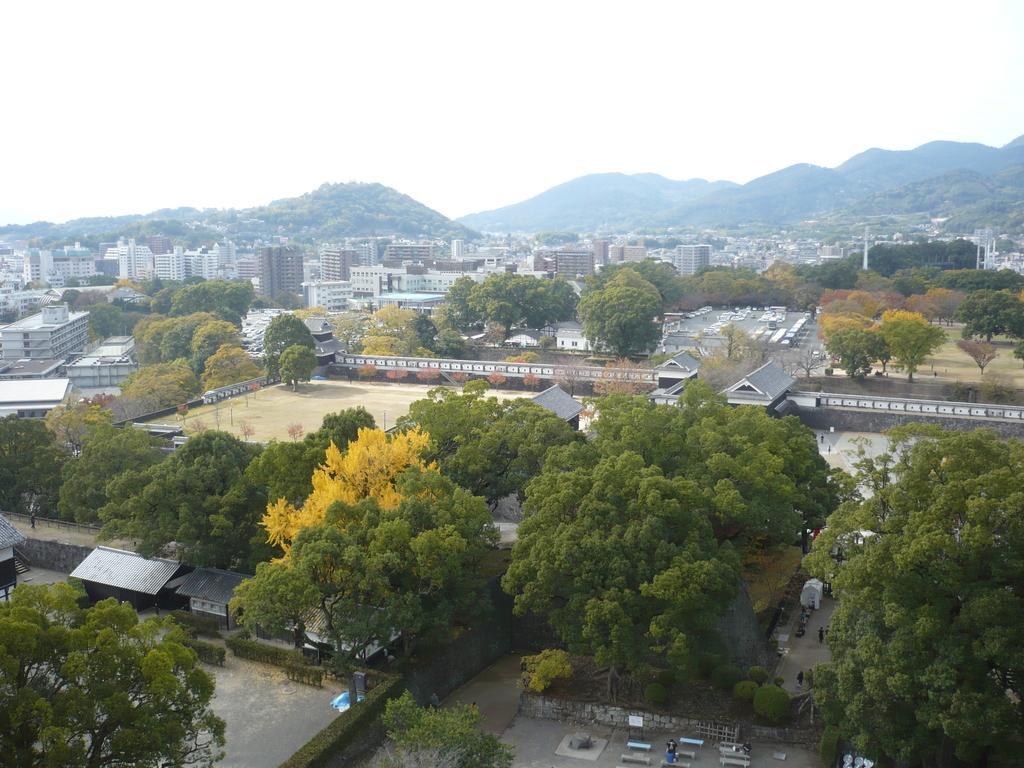Please provide a concise description of this image. In the foreground of the image we can see shutters, benches and trees. In the middle of the image we can see buildings and trees. On the top of the image we can see the sky. 